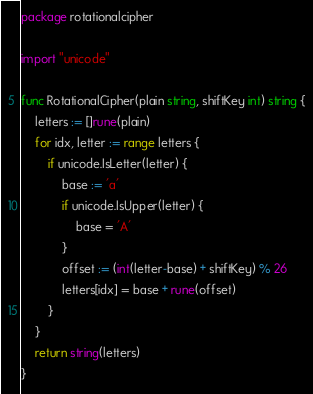<code> <loc_0><loc_0><loc_500><loc_500><_Go_>package rotationalcipher

import "unicode"

func RotationalCipher(plain string, shiftKey int) string {
	letters := []rune(plain)
	for idx, letter := range letters {
		if unicode.IsLetter(letter) {
			base := 'a'
			if unicode.IsUpper(letter) {
				base = 'A'
			}
			offset := (int(letter-base) + shiftKey) % 26
			letters[idx] = base + rune(offset)
		}
	}
	return string(letters)
}
</code> 